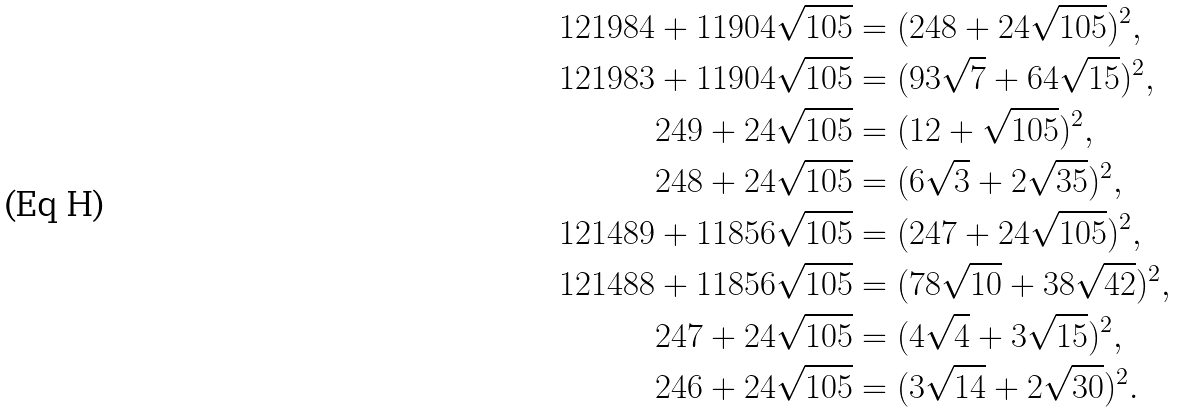Convert formula to latex. <formula><loc_0><loc_0><loc_500><loc_500>1 2 1 9 8 4 + 1 1 9 0 4 \sqrt { 1 0 5 } & = ( 2 4 8 + 2 4 \sqrt { 1 0 5 } ) ^ { 2 } , \\ 1 2 1 9 8 3 + 1 1 9 0 4 \sqrt { 1 0 5 } & = ( 9 3 \sqrt { 7 } + 6 4 \sqrt { 1 5 } ) ^ { 2 } , \\ 2 4 9 + 2 4 \sqrt { 1 0 5 } & = ( 1 2 + \sqrt { 1 0 5 } ) ^ { 2 } , \\ 2 4 8 + 2 4 \sqrt { 1 0 5 } & = ( 6 \sqrt { 3 } + 2 \sqrt { 3 5 } ) ^ { 2 } , \\ 1 2 1 4 8 9 + 1 1 8 5 6 \sqrt { 1 0 5 } & = ( 2 4 7 + 2 4 \sqrt { 1 0 5 } ) ^ { 2 } , \\ 1 2 1 4 8 8 + 1 1 8 5 6 \sqrt { 1 0 5 } & = ( 7 8 \sqrt { 1 0 } + 3 8 \sqrt { 4 2 } ) ^ { 2 } , \\ 2 4 7 + 2 4 \sqrt { 1 0 5 } & = ( 4 \sqrt { 4 } + 3 \sqrt { 1 5 } ) ^ { 2 } , \\ 2 4 6 + 2 4 \sqrt { 1 0 5 } & = ( 3 \sqrt { 1 4 } + 2 \sqrt { 3 0 } ) ^ { 2 } .</formula> 